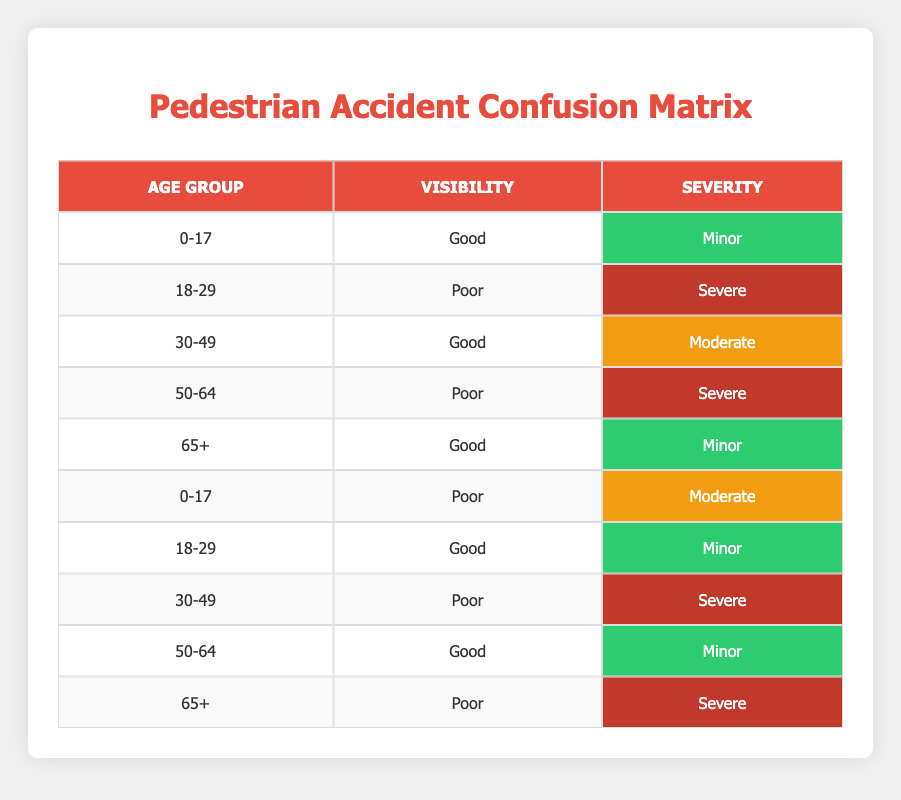What age group has the highest number of severe accidents? The severe accidents in the table are associated with the age groups 18-29, 50-64, and 30-49. Each of these age groups has one severe case. Therefore, there is no single age group with a higher count; they are all tied.
Answer: None Are there more pedestrian accidents in good visibility conditions or poor visibility conditions? In the table, accidents under good visibility conditions are as follows: 0-17 (Minor), 30-49 (Moderate), 65+ (Minor), 18-29 (Minor), and 50-64 (Minor) totaling 5. Under poor visibility, we have: 18-29 (Severe), 50-64 (Severe), 0-17 (Moderate), 30-49 (Severe), and 65+ (Severe) totaling 5. The counts are equal.
Answer: Equal Which age group experienced a moderate severity accident while visibility was poor? The age group that experienced a moderate severity accident while visibility was poor is 0-17, as indicated in the row detailing the conditions.
Answer: 0-17 What is the percentage of severe accidents among all recorded pedestrian accidents? There are a total of 10 accidents recorded in the data. The severe accidents occur 4 times (ages 18-29 and 50-64 under poor visibility and age 30-49). The percentage is (4/10) * 100 = 40%.
Answer: 40% Is it true that all age groups experienced either a minor or a severe accident? By examining the table, we see that every age group listed has either minor (0-17, 65+, 50-64, 18-29) or severe (18-29, 50-64) accidents. There are no other severity types recorded. Therefore, the statement is true.
Answer: Yes Which visibility condition is associated with the most severe accidents? Looking at the data for severe accidents, they all occur under the poor visibility conditions for ages 18-29, 50-64, and 30-49. Since poor visibility includes four entries for severe accidents (including two of the same age group), it is clear that poor visibility is associated with more severe accidents.
Answer: Poor What average severity level is associated with the 30-49 age group? The 30-49 age group has two entries: one for good visibility (Moderate) and one for poor visibility (Severe). To find the average severity level, we can assign numerical values (Minor=1, Moderate=2, Severe=3) to each severity type. This means (2 + 3) / 2 = 2.5, which corresponds to moderate severity.
Answer: Moderate 